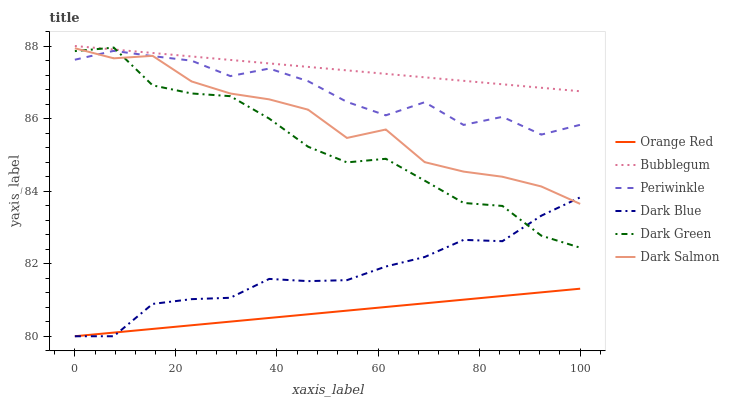Does Orange Red have the minimum area under the curve?
Answer yes or no. Yes. Does Bubblegum have the maximum area under the curve?
Answer yes or no. Yes. Does Dark Blue have the minimum area under the curve?
Answer yes or no. No. Does Dark Blue have the maximum area under the curve?
Answer yes or no. No. Is Orange Red the smoothest?
Answer yes or no. Yes. Is Periwinkle the roughest?
Answer yes or no. Yes. Is Bubblegum the smoothest?
Answer yes or no. No. Is Bubblegum the roughest?
Answer yes or no. No. Does Dark Blue have the lowest value?
Answer yes or no. Yes. Does Bubblegum have the lowest value?
Answer yes or no. No. Does Bubblegum have the highest value?
Answer yes or no. Yes. Does Dark Blue have the highest value?
Answer yes or no. No. Is Orange Red less than Periwinkle?
Answer yes or no. Yes. Is Bubblegum greater than Dark Salmon?
Answer yes or no. Yes. Does Periwinkle intersect Dark Salmon?
Answer yes or no. Yes. Is Periwinkle less than Dark Salmon?
Answer yes or no. No. Is Periwinkle greater than Dark Salmon?
Answer yes or no. No. Does Orange Red intersect Periwinkle?
Answer yes or no. No. 